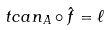Convert formula to latex. <formula><loc_0><loc_0><loc_500><loc_500>\ t c a n _ { A } \circ \hat { f } = \ell</formula> 